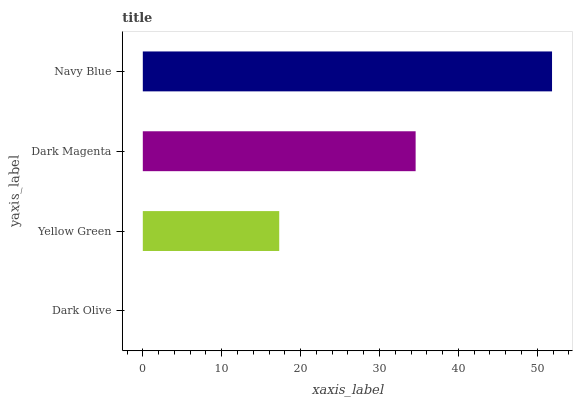Is Dark Olive the minimum?
Answer yes or no. Yes. Is Navy Blue the maximum?
Answer yes or no. Yes. Is Yellow Green the minimum?
Answer yes or no. No. Is Yellow Green the maximum?
Answer yes or no. No. Is Yellow Green greater than Dark Olive?
Answer yes or no. Yes. Is Dark Olive less than Yellow Green?
Answer yes or no. Yes. Is Dark Olive greater than Yellow Green?
Answer yes or no. No. Is Yellow Green less than Dark Olive?
Answer yes or no. No. Is Dark Magenta the high median?
Answer yes or no. Yes. Is Yellow Green the low median?
Answer yes or no. Yes. Is Navy Blue the high median?
Answer yes or no. No. Is Dark Magenta the low median?
Answer yes or no. No. 